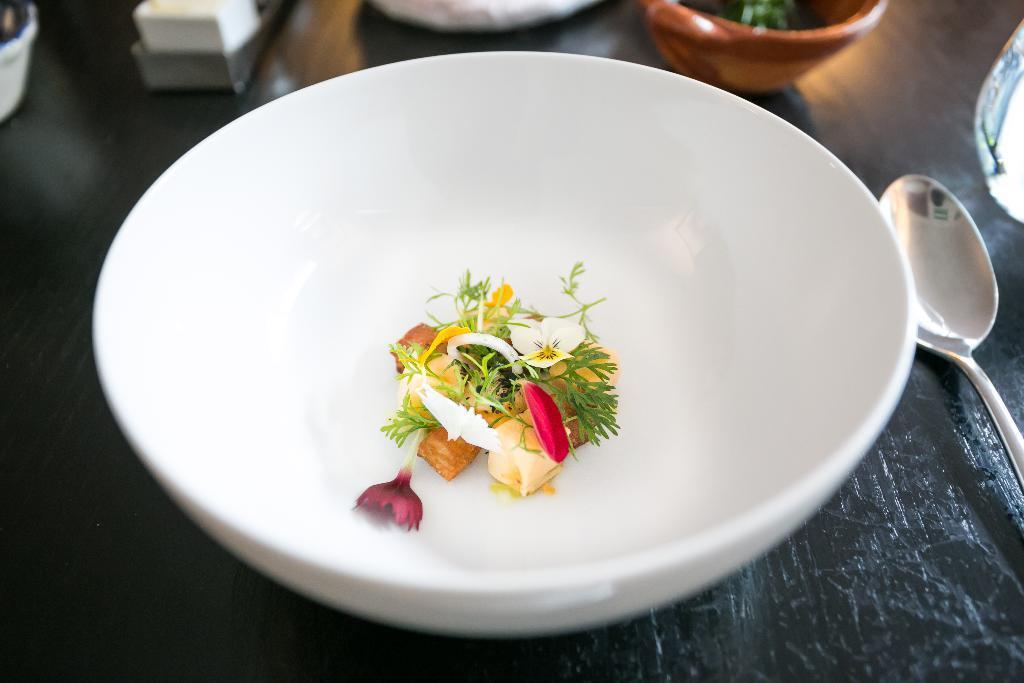Please provide a concise description of this image. In the center of the image there are flowers in a bowl. On the table we can see spoon, bowls and some objects. 